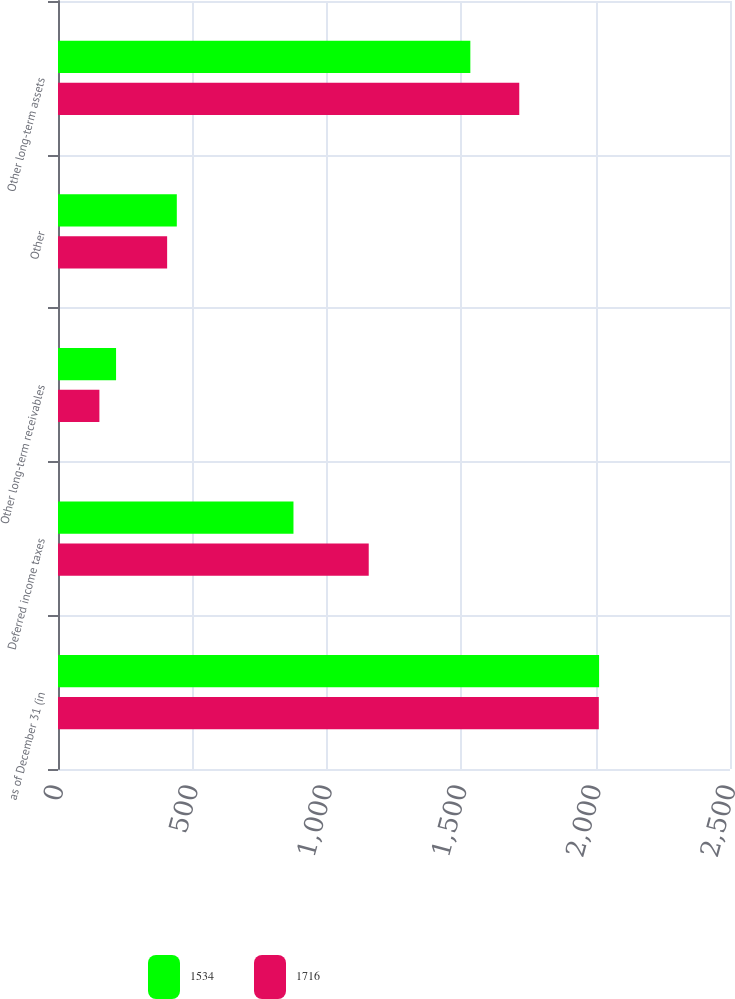<chart> <loc_0><loc_0><loc_500><loc_500><stacked_bar_chart><ecel><fcel>as of December 31 (in<fcel>Deferred income taxes<fcel>Other long-term receivables<fcel>Other<fcel>Other long-term assets<nl><fcel>1534<fcel>2013<fcel>876<fcel>216<fcel>442<fcel>1534<nl><fcel>1716<fcel>2012<fcel>1156<fcel>154<fcel>406<fcel>1716<nl></chart> 